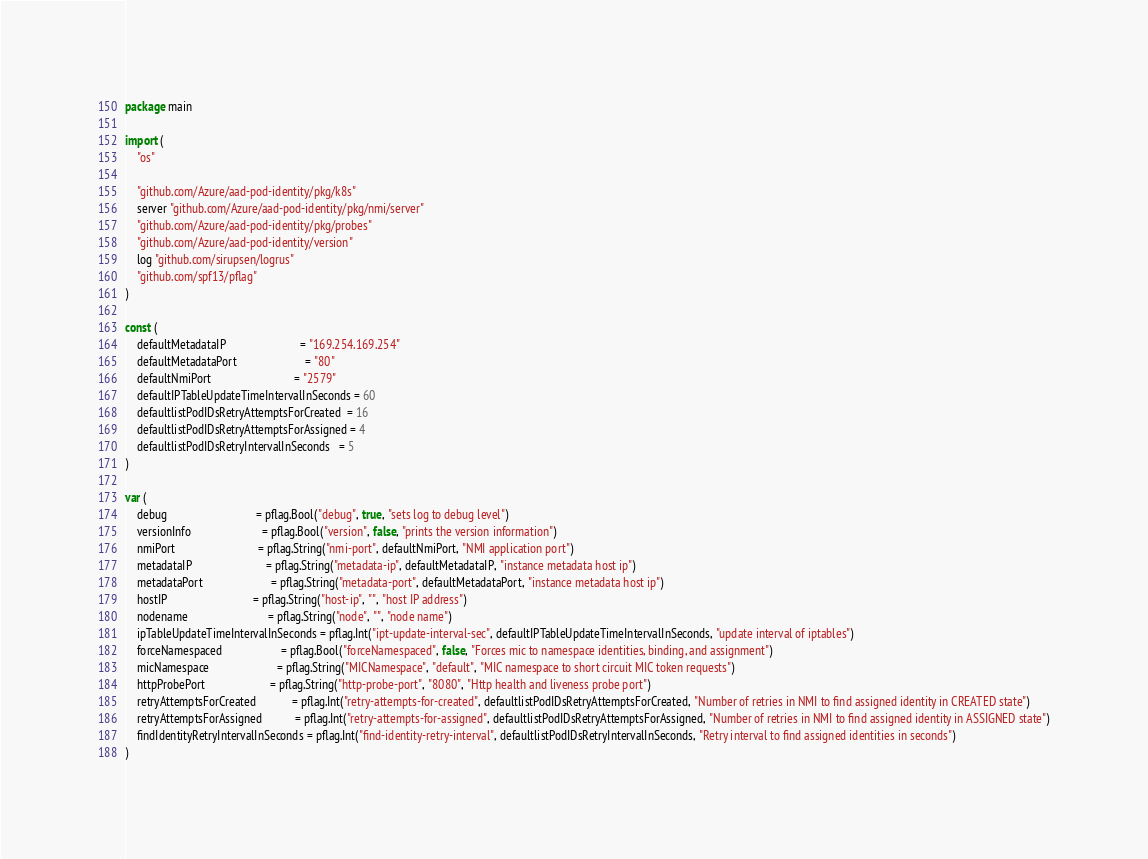Convert code to text. <code><loc_0><loc_0><loc_500><loc_500><_Go_>package main

import (
	"os"

	"github.com/Azure/aad-pod-identity/pkg/k8s"
	server "github.com/Azure/aad-pod-identity/pkg/nmi/server"
	"github.com/Azure/aad-pod-identity/pkg/probes"
	"github.com/Azure/aad-pod-identity/version"
	log "github.com/sirupsen/logrus"
	"github.com/spf13/pflag"
)

const (
	defaultMetadataIP                         = "169.254.169.254"
	defaultMetadataPort                       = "80"
	defaultNmiPort                            = "2579"
	defaultIPTableUpdateTimeIntervalInSeconds = 60
	defaultlistPodIDsRetryAttemptsForCreated  = 16
	defaultlistPodIDsRetryAttemptsForAssigned = 4
	defaultlistPodIDsRetryIntervalInSeconds   = 5
)

var (
	debug                              = pflag.Bool("debug", true, "sets log to debug level")
	versionInfo                        = pflag.Bool("version", false, "prints the version information")
	nmiPort                            = pflag.String("nmi-port", defaultNmiPort, "NMI application port")
	metadataIP                         = pflag.String("metadata-ip", defaultMetadataIP, "instance metadata host ip")
	metadataPort                       = pflag.String("metadata-port", defaultMetadataPort, "instance metadata host ip")
	hostIP                             = pflag.String("host-ip", "", "host IP address")
	nodename                           = pflag.String("node", "", "node name")
	ipTableUpdateTimeIntervalInSeconds = pflag.Int("ipt-update-interval-sec", defaultIPTableUpdateTimeIntervalInSeconds, "update interval of iptables")
	forceNamespaced                    = pflag.Bool("forceNamespaced", false, "Forces mic to namespace identities, binding, and assignment")
	micNamespace                       = pflag.String("MICNamespace", "default", "MIC namespace to short circuit MIC token requests")
	httpProbePort                      = pflag.String("http-probe-port", "8080", "Http health and liveness probe port")
	retryAttemptsForCreated            = pflag.Int("retry-attempts-for-created", defaultlistPodIDsRetryAttemptsForCreated, "Number of retries in NMI to find assigned identity in CREATED state")
	retryAttemptsForAssigned           = pflag.Int("retry-attempts-for-assigned", defaultlistPodIDsRetryAttemptsForAssigned, "Number of retries in NMI to find assigned identity in ASSIGNED state")
	findIdentityRetryIntervalInSeconds = pflag.Int("find-identity-retry-interval", defaultlistPodIDsRetryIntervalInSeconds, "Retry interval to find assigned identities in seconds")
)
</code> 